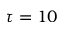Convert formula to latex. <formula><loc_0><loc_0><loc_500><loc_500>\tau = 1 0</formula> 